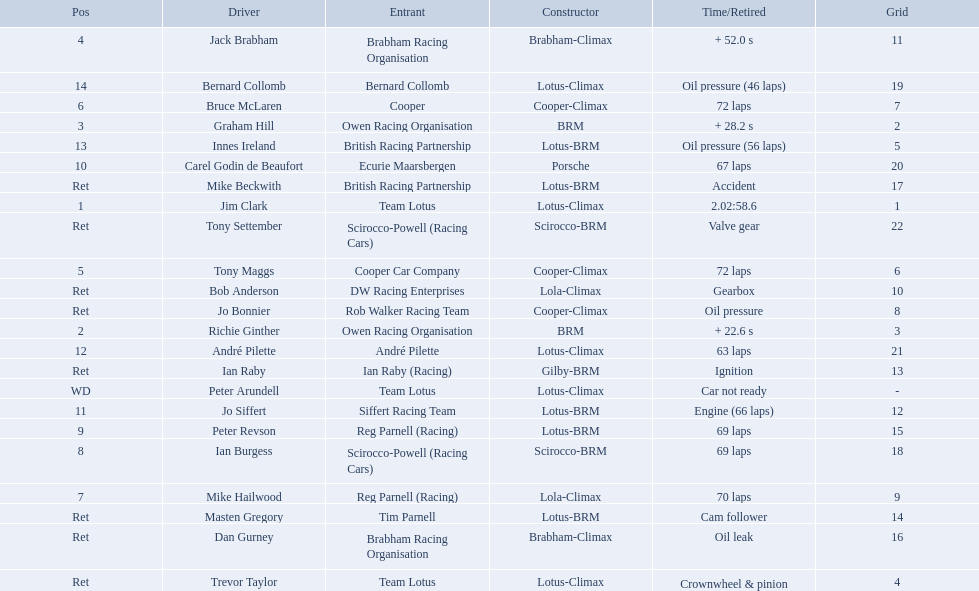Who were the drivers at the 1963 international gold cup? Jim Clark, Richie Ginther, Graham Hill, Jack Brabham, Tony Maggs, Bruce McLaren, Mike Hailwood, Ian Burgess, Peter Revson, Carel Godin de Beaufort, Jo Siffert, André Pilette, Innes Ireland, Bernard Collomb, Ian Raby, Dan Gurney, Mike Beckwith, Masten Gregory, Trevor Taylor, Jo Bonnier, Tony Settember, Bob Anderson, Peter Arundell. What was tony maggs position? 5. What was jo siffert? 11. Who came in earlier? Tony Maggs. 